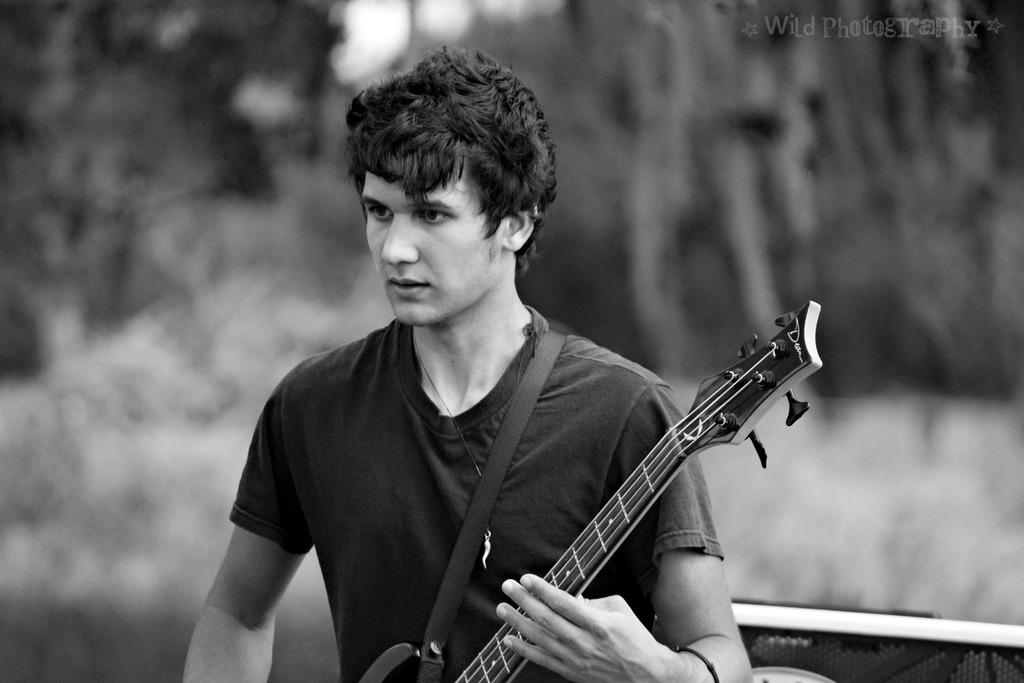What is the man in the image doing? The man is playing a guitar in the image. What can be seen in the background of the image? There are trees in the background of the image. How many frogs are sitting on the man's underwear in the image? There are no frogs or underwear present in the image, so this question cannot be answered. 